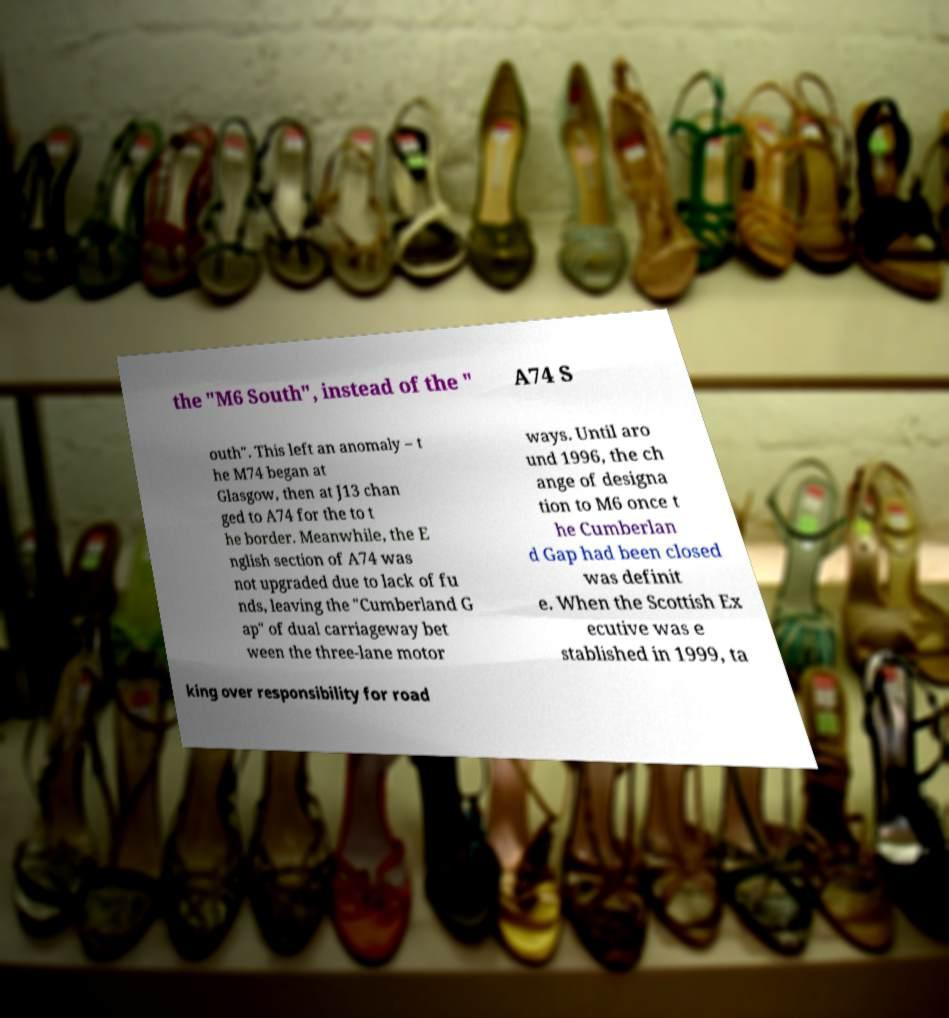Please read and relay the text visible in this image. What does it say? the "M6 South", instead of the " A74 S outh". This left an anomaly – t he M74 began at Glasgow, then at J13 chan ged to A74 for the to t he border. Meanwhile, the E nglish section of A74 was not upgraded due to lack of fu nds, leaving the "Cumberland G ap" of dual carriageway bet ween the three-lane motor ways. Until aro und 1996, the ch ange of designa tion to M6 once t he Cumberlan d Gap had been closed was definit e. When the Scottish Ex ecutive was e stablished in 1999, ta king over responsibility for road 